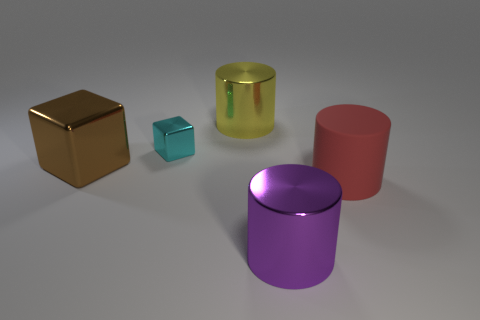Add 2 tiny blocks. How many objects exist? 7 Subtract all blocks. How many objects are left? 3 Add 3 yellow cylinders. How many yellow cylinders are left? 4 Add 5 big brown objects. How many big brown objects exist? 6 Subtract 0 purple spheres. How many objects are left? 5 Subtract all big purple cylinders. Subtract all brown metal blocks. How many objects are left? 3 